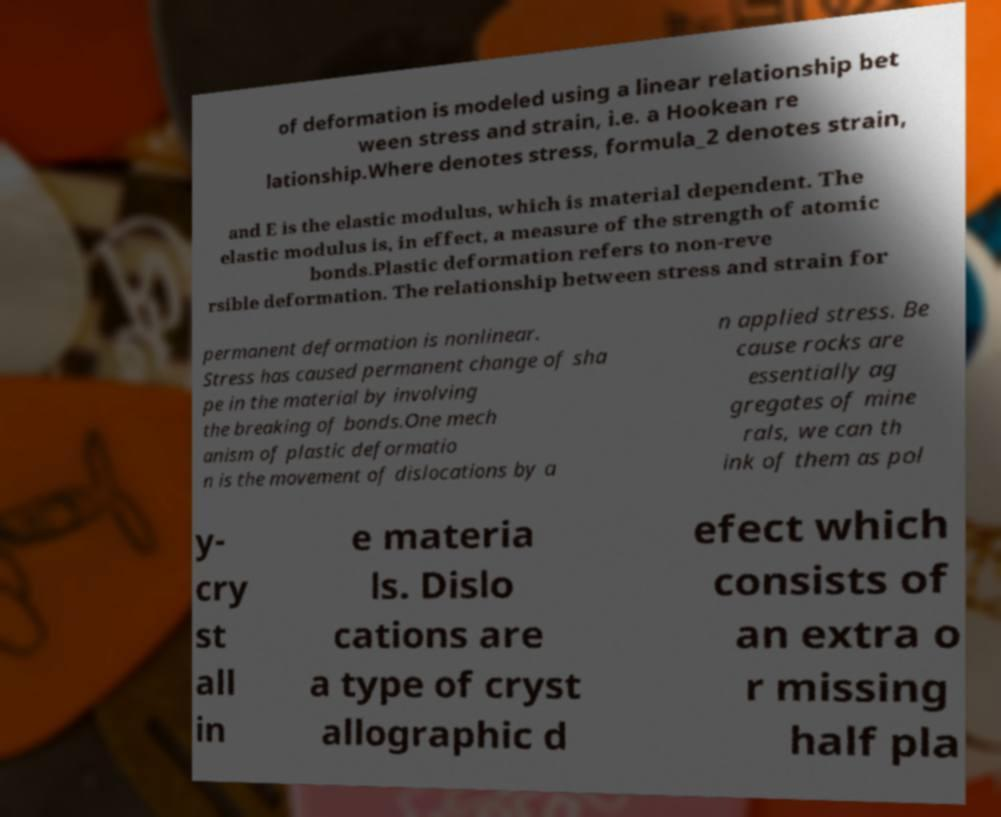Could you assist in decoding the text presented in this image and type it out clearly? of deformation is modeled using a linear relationship bet ween stress and strain, i.e. a Hookean re lationship.Where denotes stress, formula_2 denotes strain, and E is the elastic modulus, which is material dependent. The elastic modulus is, in effect, a measure of the strength of atomic bonds.Plastic deformation refers to non-reve rsible deformation. The relationship between stress and strain for permanent deformation is nonlinear. Stress has caused permanent change of sha pe in the material by involving the breaking of bonds.One mech anism of plastic deformatio n is the movement of dislocations by a n applied stress. Be cause rocks are essentially ag gregates of mine rals, we can th ink of them as pol y- cry st all in e materia ls. Dislo cations are a type of cryst allographic d efect which consists of an extra o r missing half pla 